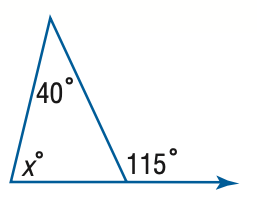Question: Find x.
Choices:
A. 40
B. 55
C. 65
D. 75
Answer with the letter. Answer: D 